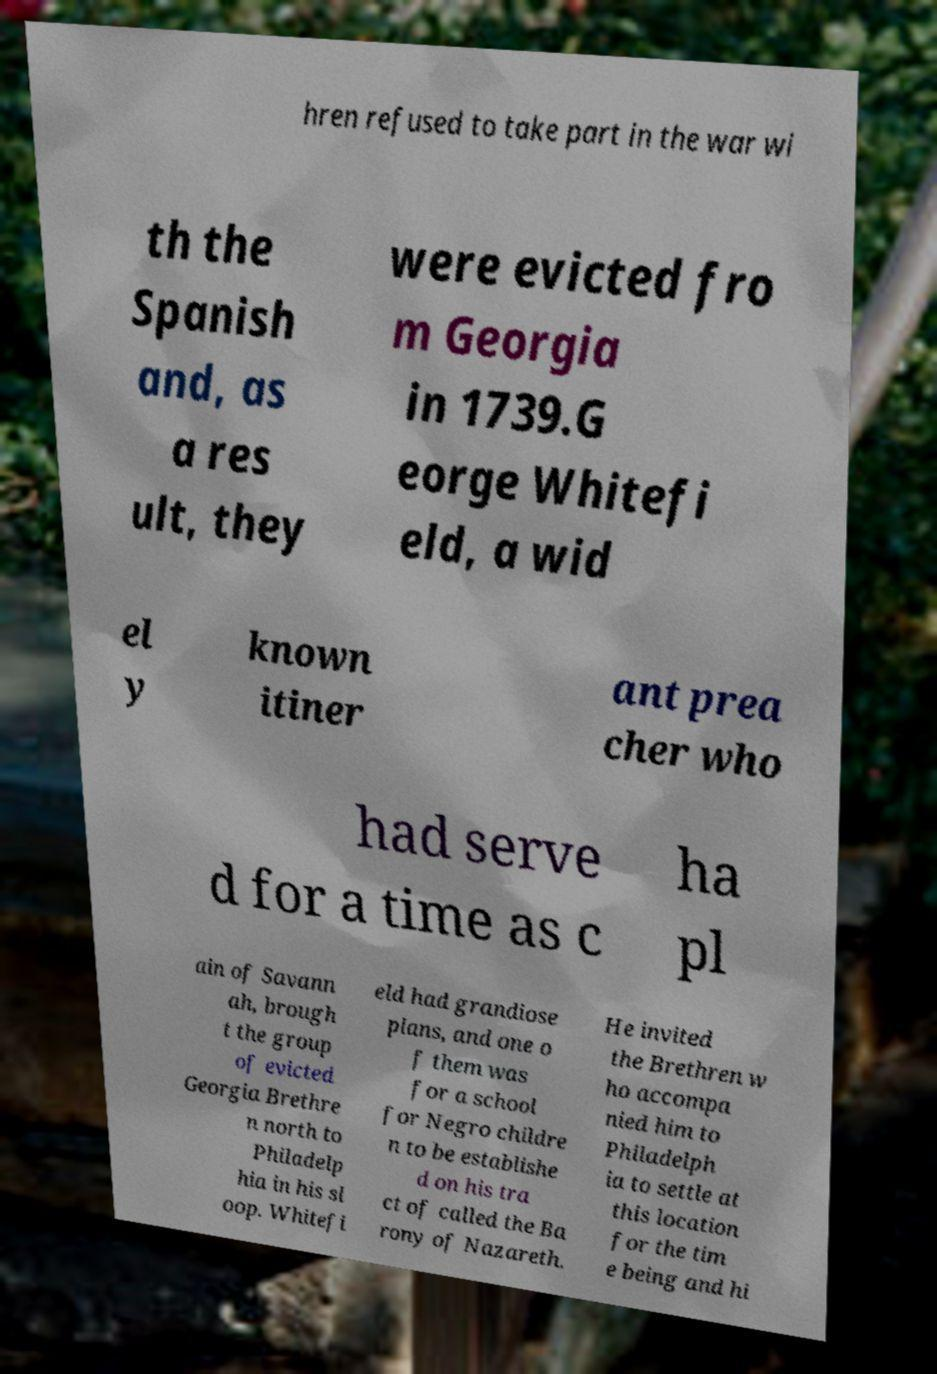Please read and relay the text visible in this image. What does it say? hren refused to take part in the war wi th the Spanish and, as a res ult, they were evicted fro m Georgia in 1739.G eorge Whitefi eld, a wid el y known itiner ant prea cher who had serve d for a time as c ha pl ain of Savann ah, brough t the group of evicted Georgia Brethre n north to Philadelp hia in his sl oop. Whitefi eld had grandiose plans, and one o f them was for a school for Negro childre n to be establishe d on his tra ct of called the Ba rony of Nazareth. He invited the Brethren w ho accompa nied him to Philadelph ia to settle at this location for the tim e being and hi 